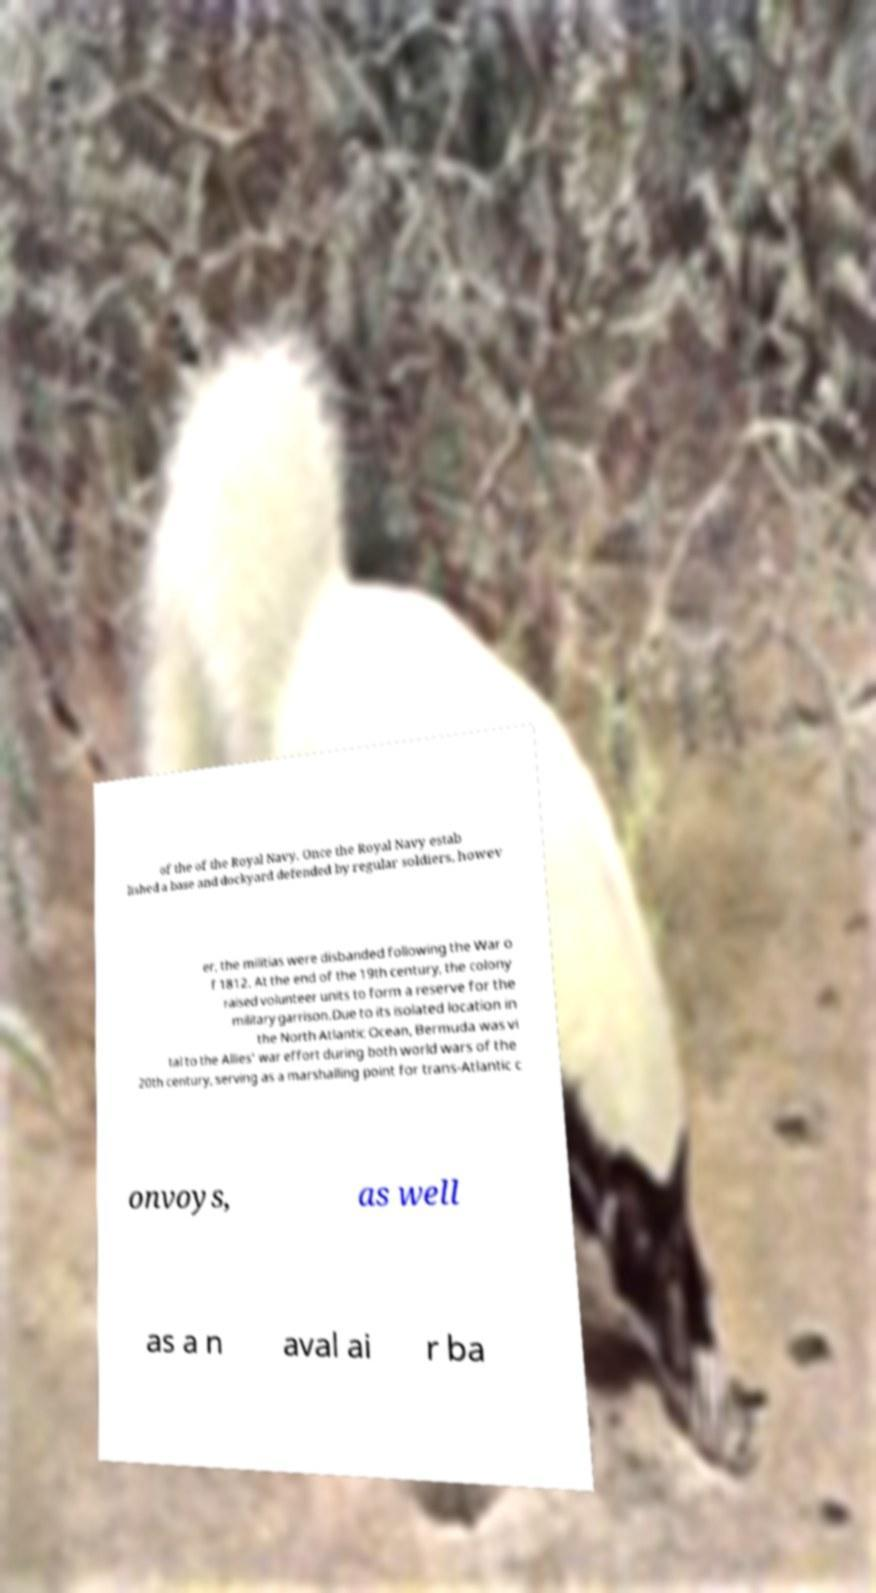Please identify and transcribe the text found in this image. of the of the Royal Navy. Once the Royal Navy estab lished a base and dockyard defended by regular soldiers, howev er, the militias were disbanded following the War o f 1812. At the end of the 19th century, the colony raised volunteer units to form a reserve for the military garrison.Due to its isolated location in the North Atlantic Ocean, Bermuda was vi tal to the Allies' war effort during both world wars of the 20th century, serving as a marshalling point for trans-Atlantic c onvoys, as well as a n aval ai r ba 